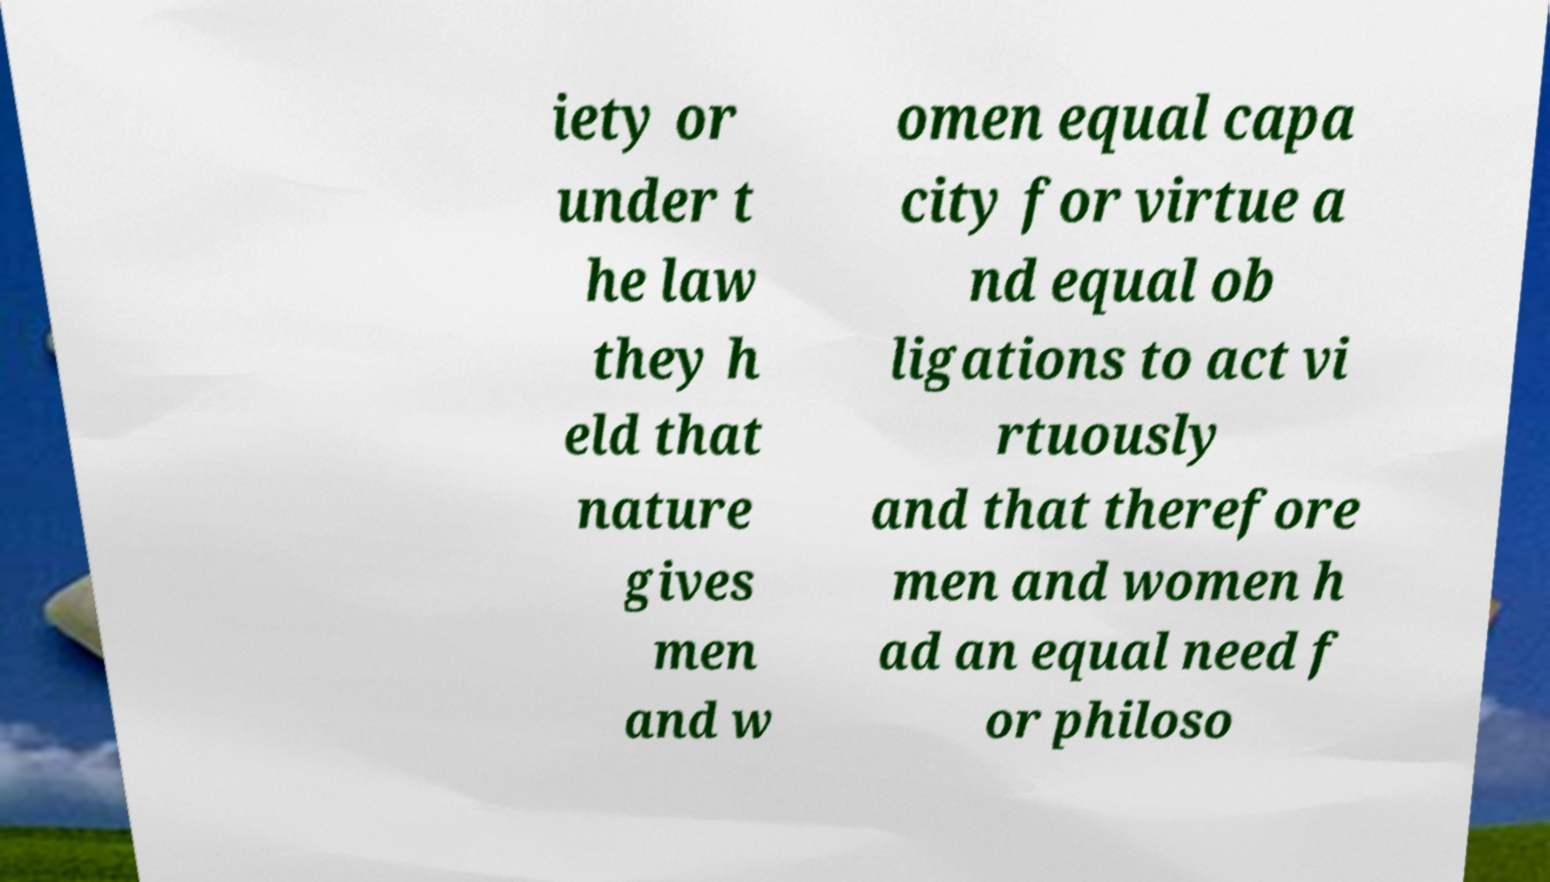Could you assist in decoding the text presented in this image and type it out clearly? iety or under t he law they h eld that nature gives men and w omen equal capa city for virtue a nd equal ob ligations to act vi rtuously and that therefore men and women h ad an equal need f or philoso 